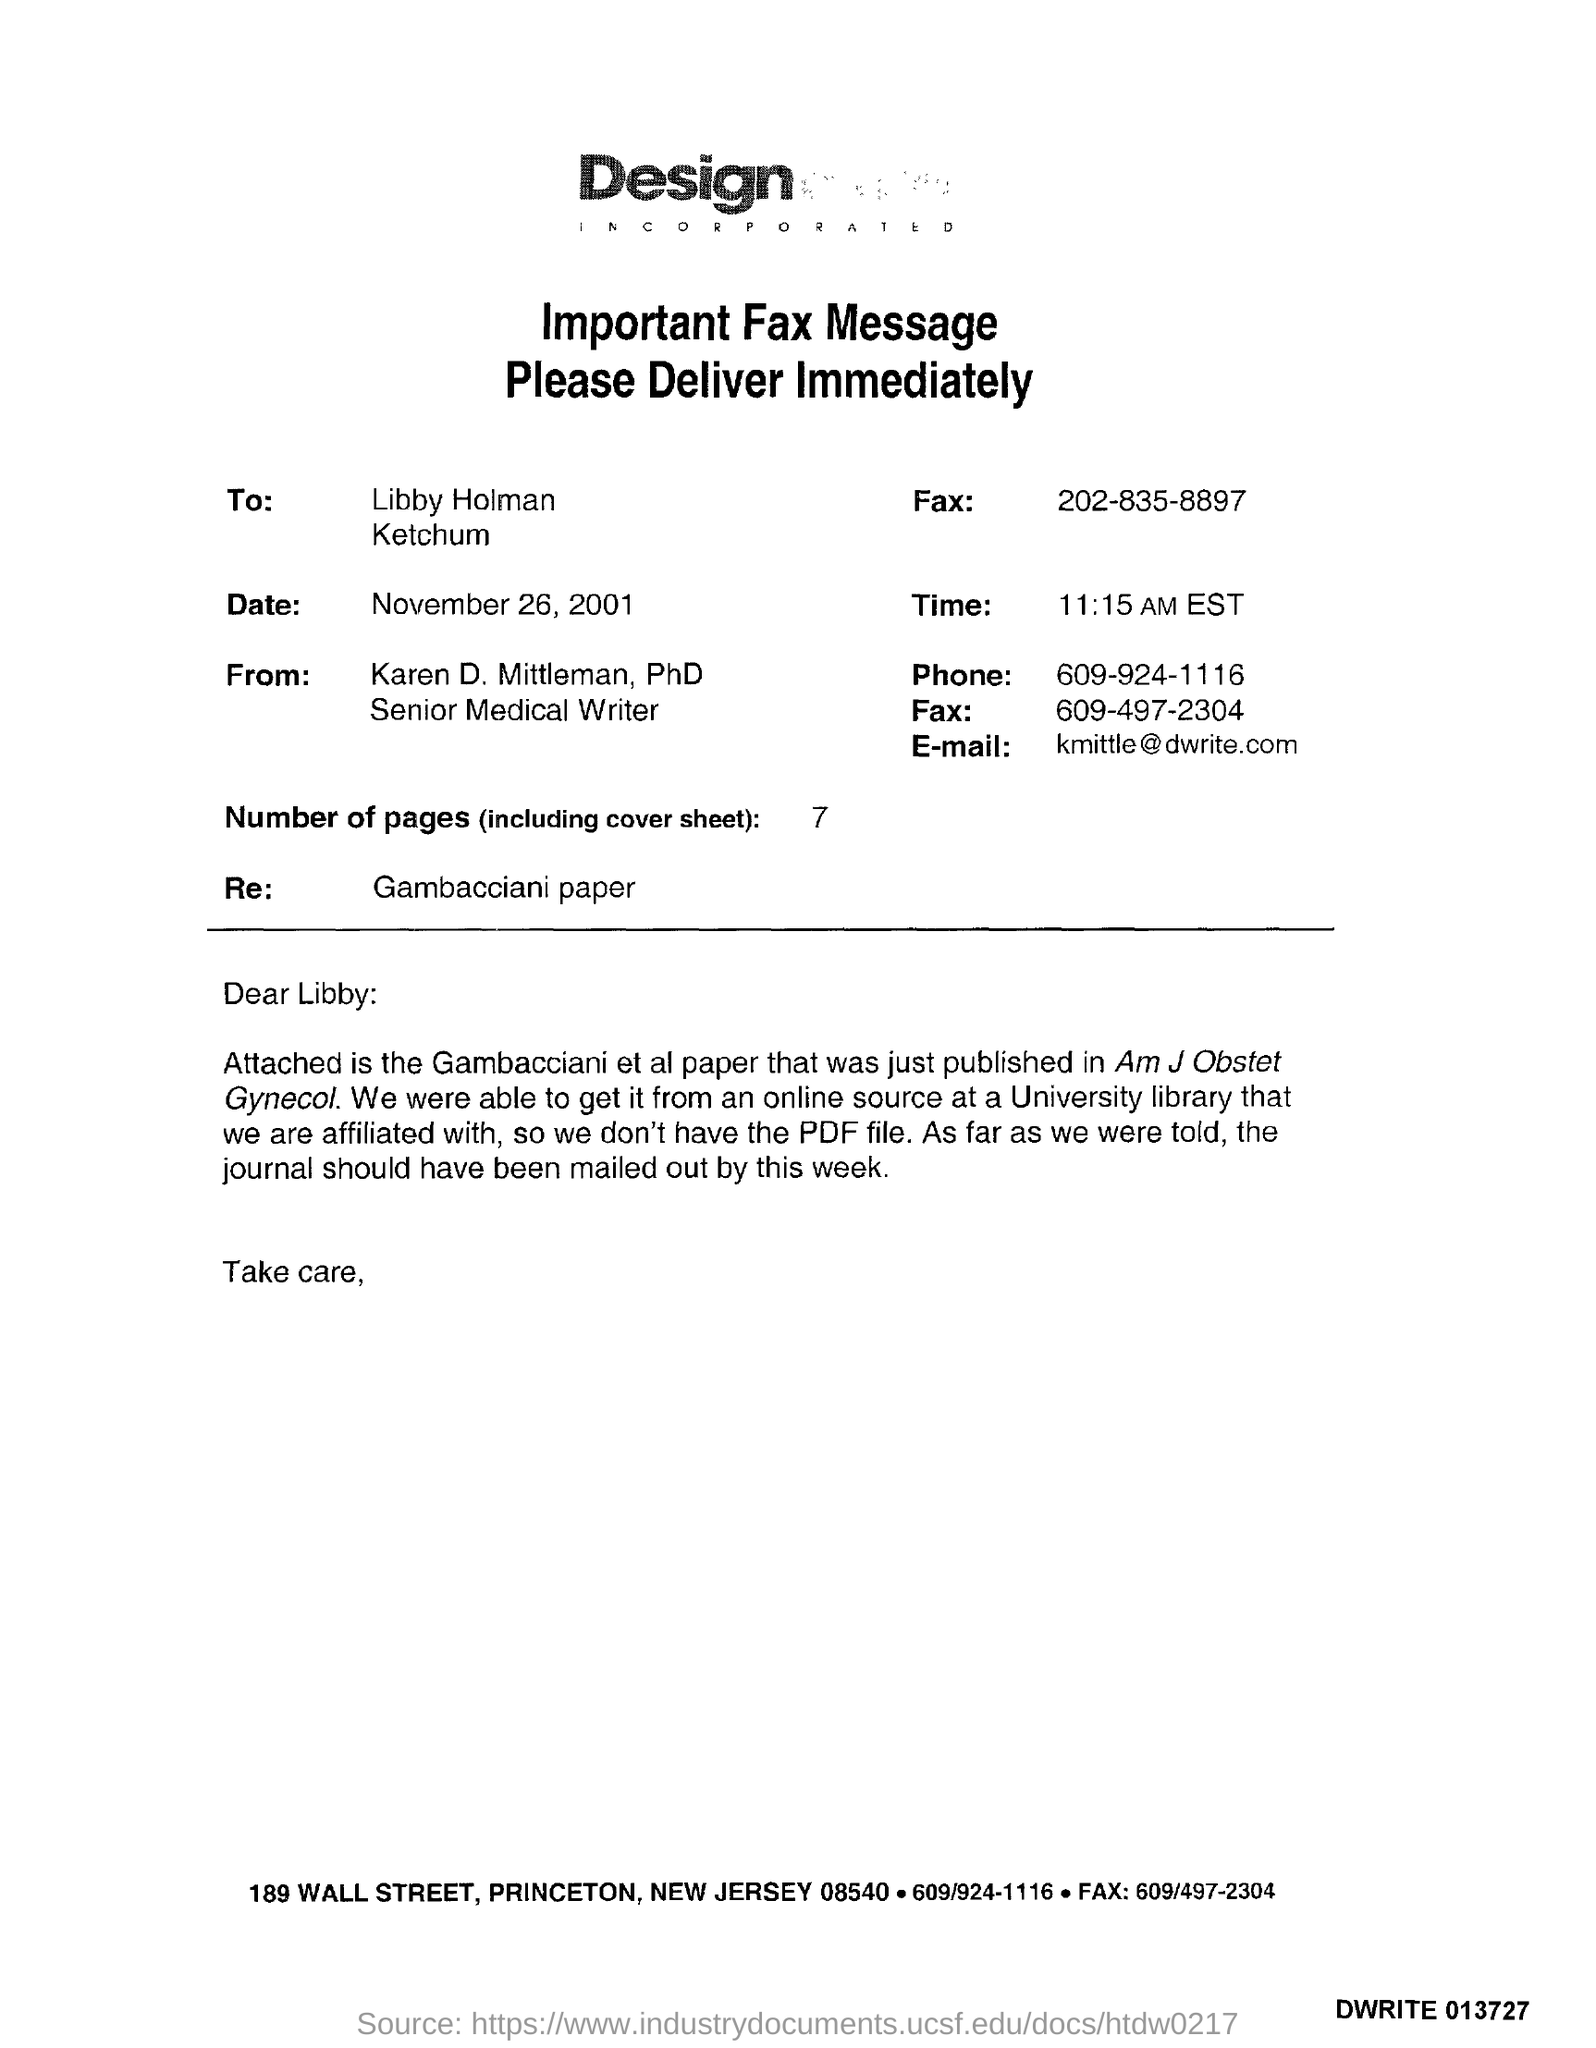List a handful of essential elements in this visual. The current time is 11:15 AM EST. On November 26, 2001, the date is November 26, 2001. The number of pages is 7. The e-mail address is kmittle@dwrite.com. The salutation of the letter is "Dear Libby:... 